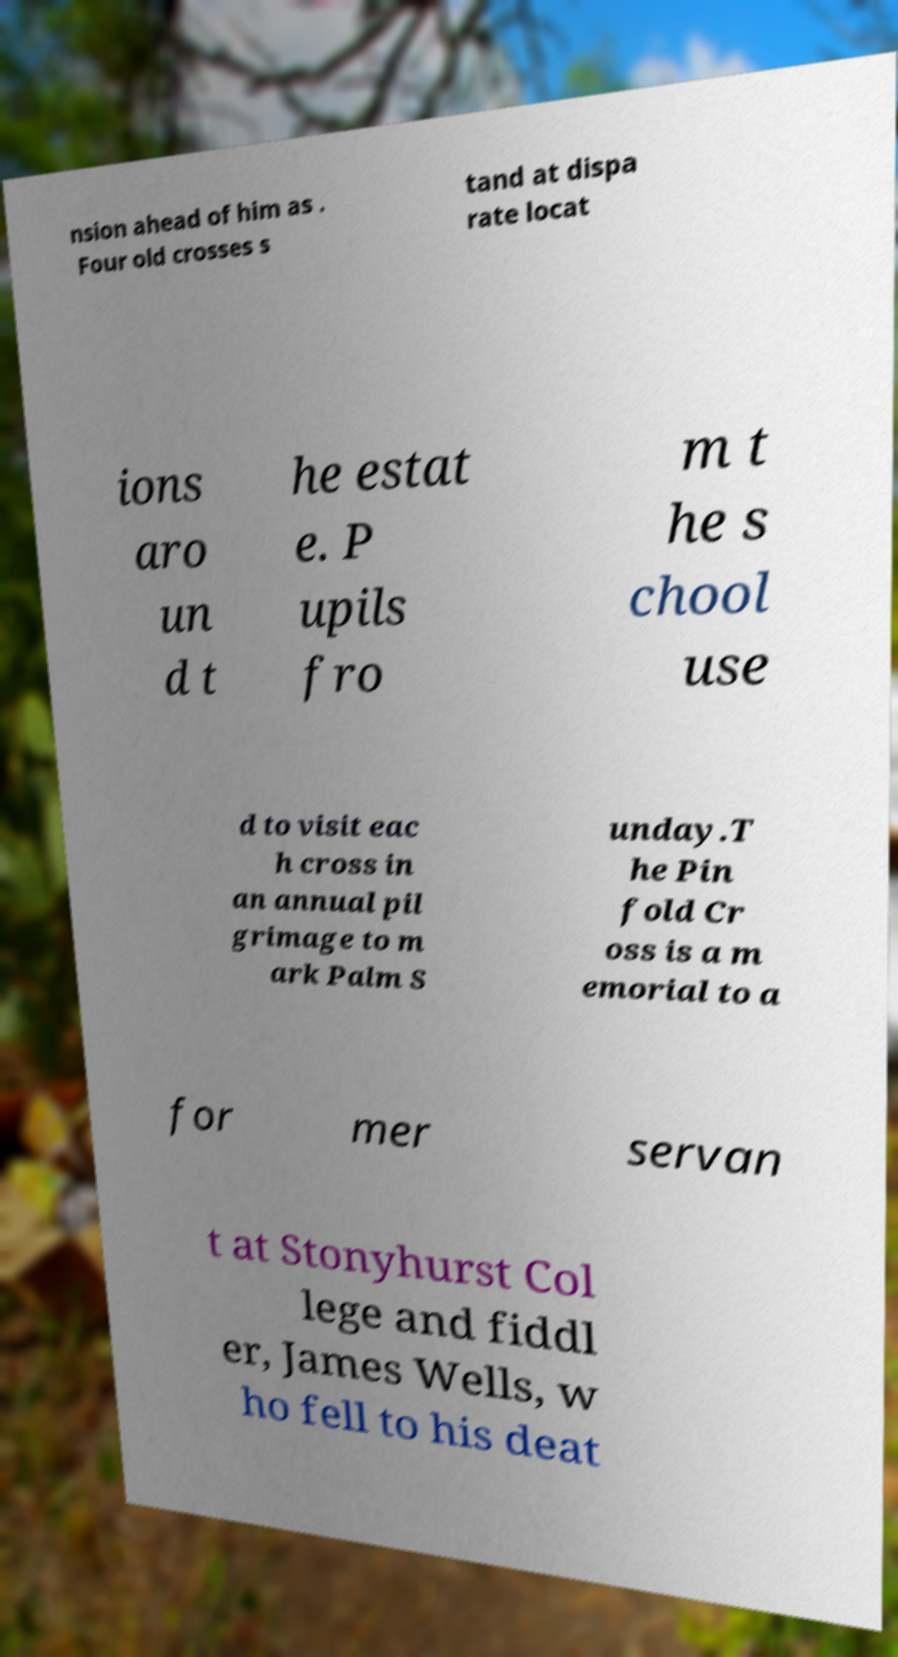Can you accurately transcribe the text from the provided image for me? nsion ahead of him as . Four old crosses s tand at dispa rate locat ions aro un d t he estat e. P upils fro m t he s chool use d to visit eac h cross in an annual pil grimage to m ark Palm S unday.T he Pin fold Cr oss is a m emorial to a for mer servan t at Stonyhurst Col lege and fiddl er, James Wells, w ho fell to his deat 